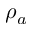<formula> <loc_0><loc_0><loc_500><loc_500>\rho _ { a }</formula> 